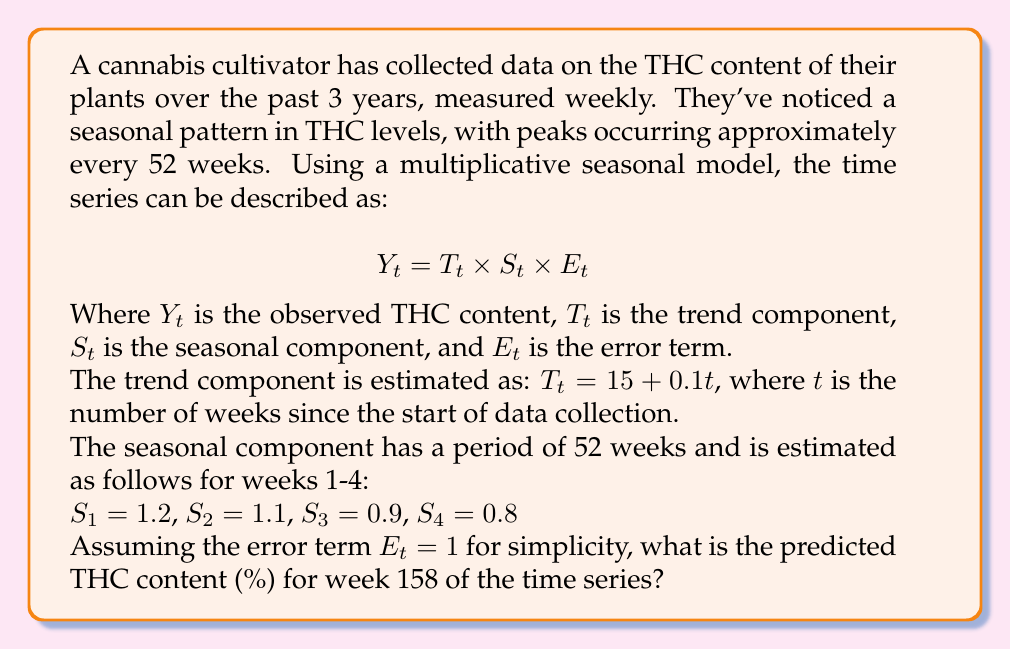Show me your answer to this math problem. To solve this problem, we need to follow these steps:

1. Calculate the trend component $T_t$ for week 158:
   $$T_{158} = 15 + 0.1(158) = 15 + 15.8 = 30.8$$

2. Determine the appropriate seasonal component $S_t$ for week 158:
   - Since the seasonal pattern repeats every 52 weeks, we need to find the equivalent week within the 52-week cycle.
   - $158 \equiv 2 \pmod{52}$ (158 divided by 52 leaves a remainder of 2)
   - Therefore, we use $S_2 = 1.1$

3. Recall that we're assuming $E_t = 1$ for simplicity.

4. Apply the multiplicative seasonal model formula:
   $$Y_{158} = T_{158} \times S_2 \times E_{158}$$
   $$Y_{158} = 30.8 \times 1.1 \times 1$$
   $$Y_{158} = 33.88$$

Thus, the predicted THC content for week 158 is 33.88%.
Answer: 33.88% 